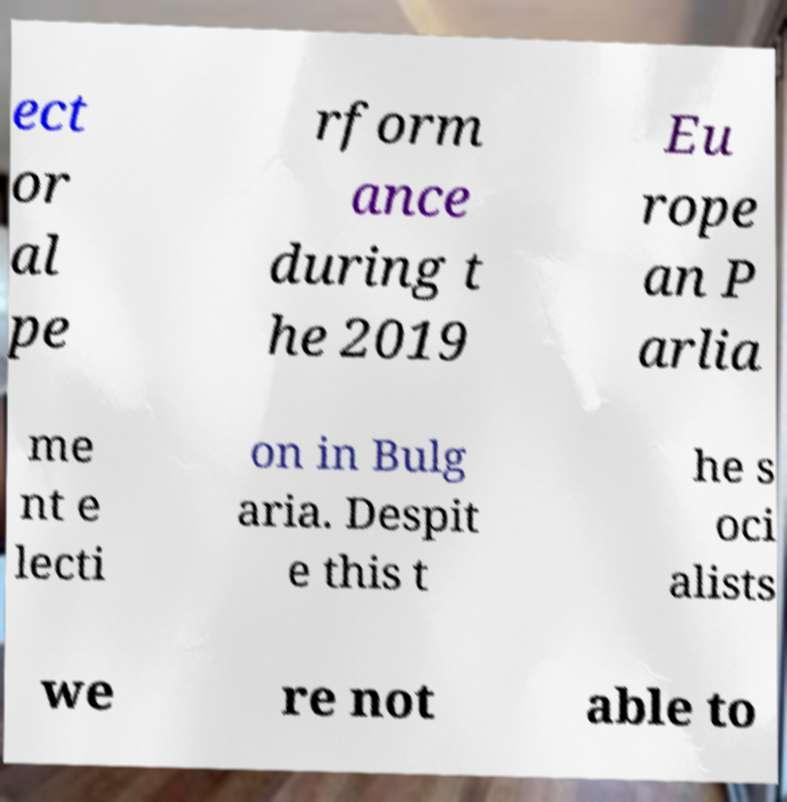Could you extract and type out the text from this image? ect or al pe rform ance during t he 2019 Eu rope an P arlia me nt e lecti on in Bulg aria. Despit e this t he s oci alists we re not able to 